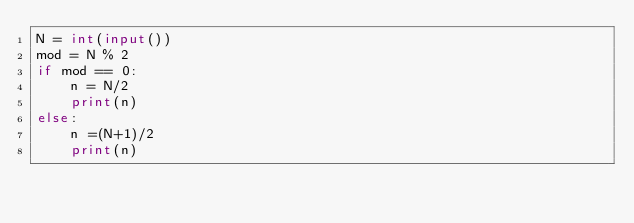Convert code to text. <code><loc_0><loc_0><loc_500><loc_500><_Python_>N = int(input())
mod = N % 2
if mod == 0:
    n = N/2
    print(n)
else:
    n =(N+1)/2
    print(n)</code> 